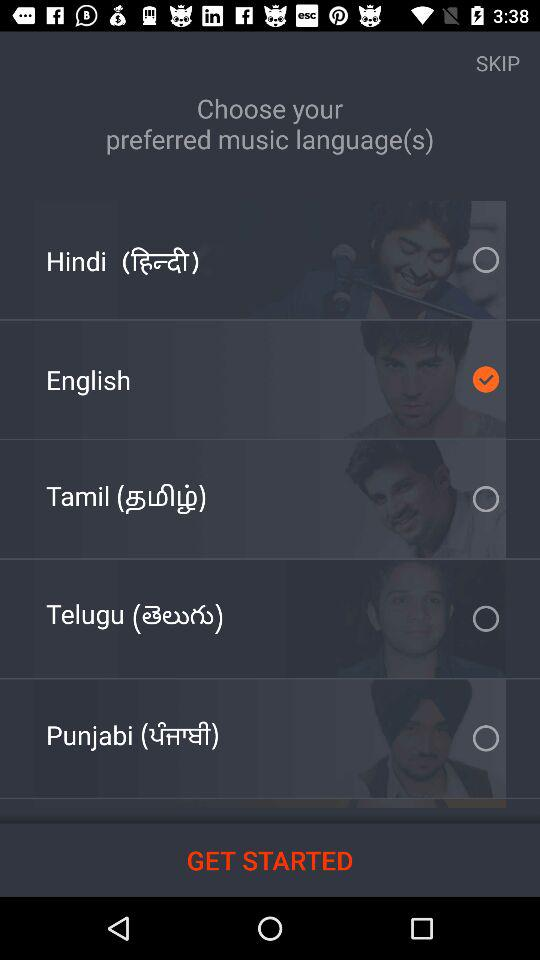How many languages are there to choose from?
Answer the question using a single word or phrase. 5 